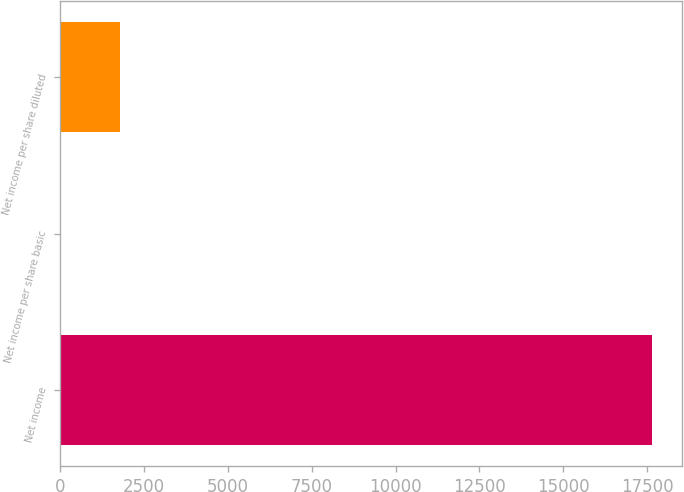Convert chart to OTSL. <chart><loc_0><loc_0><loc_500><loc_500><bar_chart><fcel>Net income<fcel>Net income per share basic<fcel>Net income per share diluted<nl><fcel>17652<fcel>0.31<fcel>1765.48<nl></chart> 